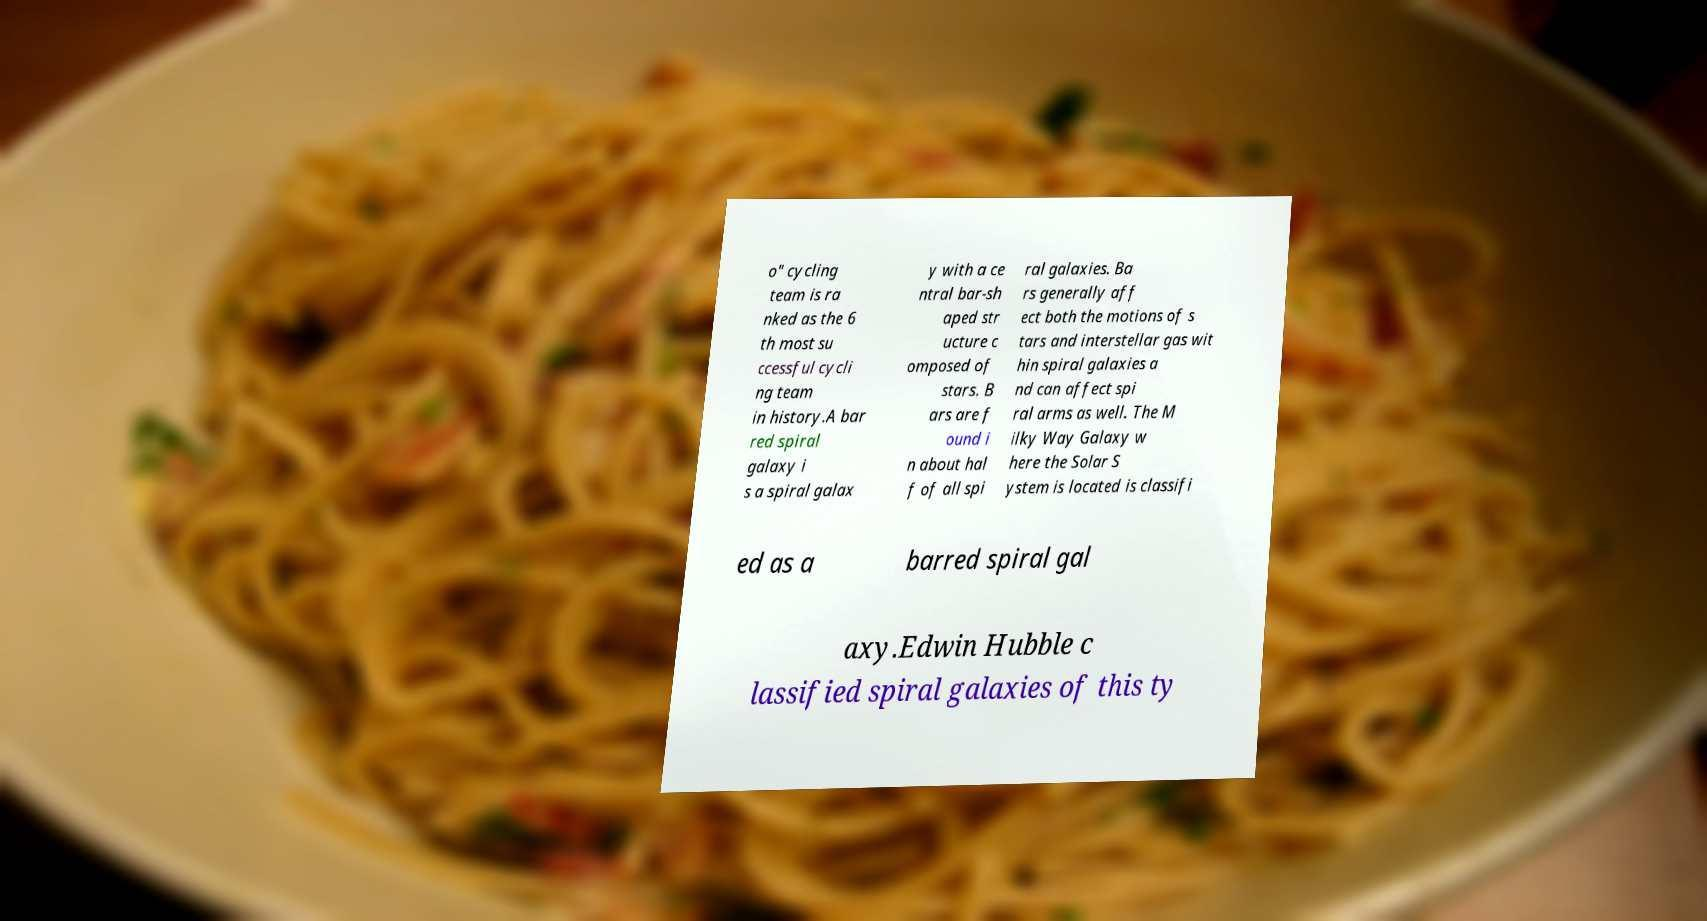Could you assist in decoding the text presented in this image and type it out clearly? o" cycling team is ra nked as the 6 th most su ccessful cycli ng team in history.A bar red spiral galaxy i s a spiral galax y with a ce ntral bar-sh aped str ucture c omposed of stars. B ars are f ound i n about hal f of all spi ral galaxies. Ba rs generally aff ect both the motions of s tars and interstellar gas wit hin spiral galaxies a nd can affect spi ral arms as well. The M ilky Way Galaxy w here the Solar S ystem is located is classifi ed as a barred spiral gal axy.Edwin Hubble c lassified spiral galaxies of this ty 